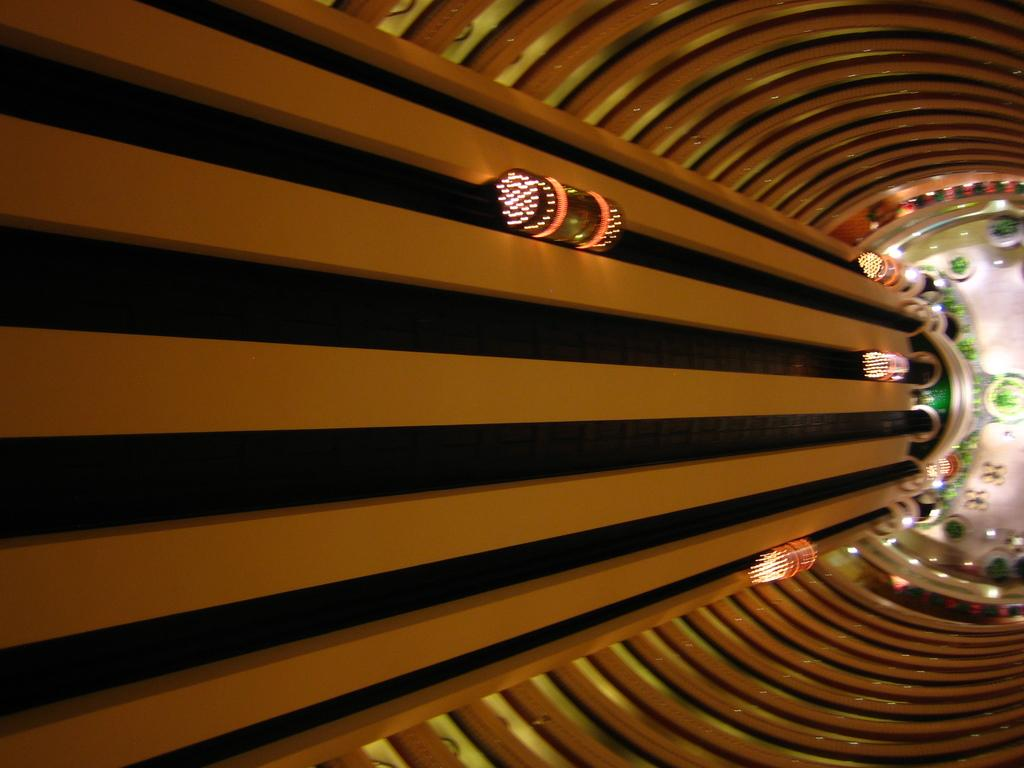What type of structure is visible in the image? There is a building in the image. What feature of the building is mentioned in the facts? The building has elevators. What are the elevators doing in the image? The elevators are going up and down. What else can be seen related to the elevators? There are lights above the elevators. How many shelves are visible in the image? There are no shelves visible in the image. What type of stretch can be seen in the image? There is no stretch visible in the image. 